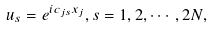Convert formula to latex. <formula><loc_0><loc_0><loc_500><loc_500>u _ { s } = e ^ { i c _ { j s } x _ { j } } , s = 1 , 2 , \cdots , 2 N ,</formula> 